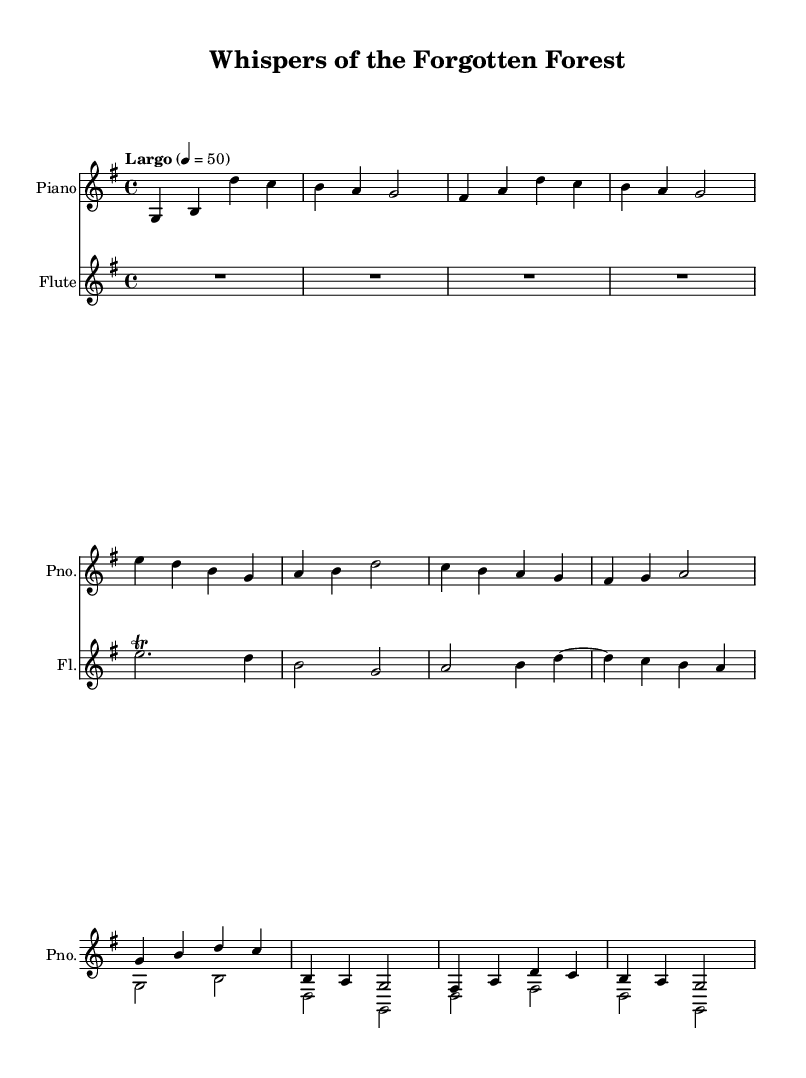What is the key signature of this music? The key signature is G major, which has one sharp (F#). This can be seen at the beginning of the staff, indicating the tonal center for the piece.
Answer: G major What is the time signature of this music? The time signature is 4/4, indicated at the beginning of the score. This means there are four beats in each measure, and the quarter note gets one beat.
Answer: 4/4 What is the tempo marking for this composition? The tempo marking is "Largo" which indicates a slow and broad tempo. It is specified at the beginning, along with the metronome marking of 50 beats per minute.
Answer: Largo How many measures are there in the piano part? There are 12 measures in the piano part. This can be counted by looking at the bar lines in the piano staff, which separate each measure.
Answer: 12 measures Which instrument accompanies the piano part? The flute accompanies the piano part, as indicated by the notation for the flute on the second staff. This instrument adds to the gentle ambiance of the piece.
Answer: Flute What musical technique is used in the flute part after the rest? A trill is used in the flute part after the rest. This technique is indicated by the notation "trill," which means to rapidly alternate between two adjacent notes.
Answer: Trill What type of ambiance is represented in the music? The music evokes a forest ambiance with rustling leaves, as suggested by the title and the serene tonalities which mimic natural sounds.
Answer: Forest ambiance 